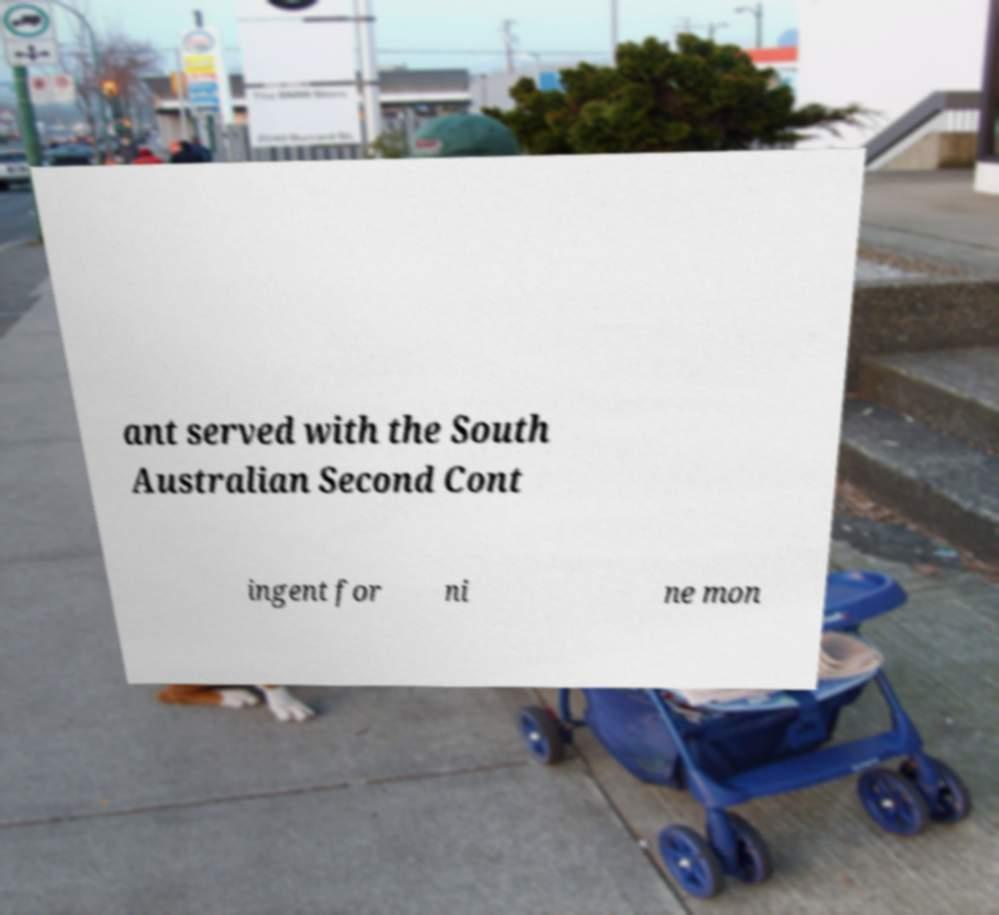Can you read and provide the text displayed in the image?This photo seems to have some interesting text. Can you extract and type it out for me? ant served with the South Australian Second Cont ingent for ni ne mon 